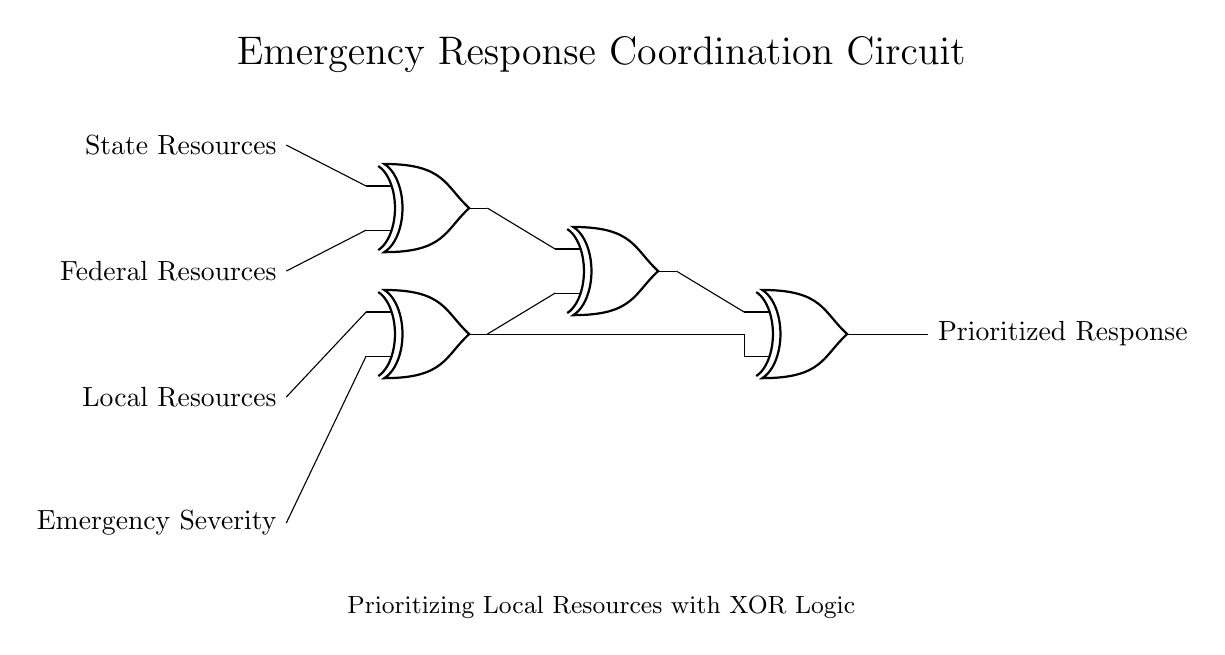What type of logic gates are used in this circuit? The circuit exclusively utilizes XOR gates, as indicated by the specific symbols representing the gates throughout the diagram.
Answer: XOR gates How many input sources are there in the circuit? The circuit features four distinct input sources, as labeled on the left: State Resources, Federal Resources, Local Resources, and Emergency Severity.
Answer: Four What is the output of this circuit labeled as? The output from the circuit is labeled as "Prioritized Response," showing the final prioritized result of the XOR operations.
Answer: Prioritized Response Which two inputs are connected to the first XOR gate? The first XOR gate is connected to the inputs labeled State Resources and Federal Resources, as represented by the connections leading into the gate from these sources.
Answer: State Resources and Federal Resources What is the relationship between the Emergency Severity input and the Local Resources input? In the circuit, the Emergency Severity input is connected to the second XOR gate, which takes the Emergency Severity and Local Resources as inputs, indicating it evaluates their relationship to produce an output.
Answer: Connected via XOR gate How does the circuit prioritize local resources in an emergency? The circuit prioritizes local resources by utilizing XOR logic to compare inputs, ensuring that the response aligns closely with local resource availability in conjunction with other state and federal inputs, and determining the most appropriate response output based on their combinations.
Answer: By evaluating with XOR logic What happens to the output if only State Resources and Local Resources are active? If only State Resources and Local Resources are active, the first XOR gate produces an output equivalent to the state resources status, and the second XOR gate combines it with Emergency Severity, ultimately leading to a prioritized response based solely on the state level of input.
Answer: State Resources status determines the output 